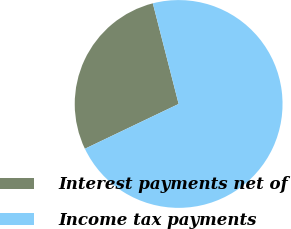Convert chart to OTSL. <chart><loc_0><loc_0><loc_500><loc_500><pie_chart><fcel>Interest payments net of<fcel>Income tax payments<nl><fcel>28.1%<fcel>71.9%<nl></chart> 